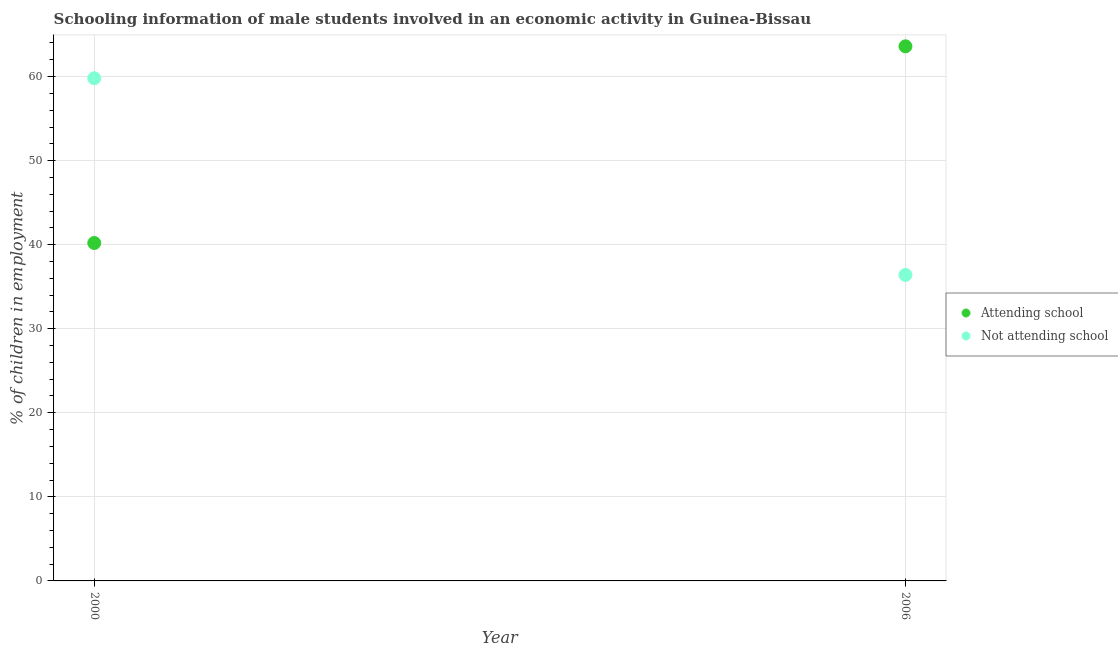How many different coloured dotlines are there?
Your response must be concise. 2. Is the number of dotlines equal to the number of legend labels?
Provide a succinct answer. Yes. What is the percentage of employed males who are attending school in 2000?
Keep it short and to the point. 40.2. Across all years, what is the maximum percentage of employed males who are not attending school?
Ensure brevity in your answer.  59.8. Across all years, what is the minimum percentage of employed males who are attending school?
Provide a succinct answer. 40.2. In which year was the percentage of employed males who are not attending school minimum?
Keep it short and to the point. 2006. What is the total percentage of employed males who are attending school in the graph?
Provide a short and direct response. 103.8. What is the difference between the percentage of employed males who are attending school in 2000 and that in 2006?
Offer a very short reply. -23.4. What is the difference between the percentage of employed males who are attending school in 2006 and the percentage of employed males who are not attending school in 2000?
Offer a terse response. 3.8. What is the average percentage of employed males who are attending school per year?
Provide a succinct answer. 51.9. In the year 2000, what is the difference between the percentage of employed males who are not attending school and percentage of employed males who are attending school?
Keep it short and to the point. 19.6. In how many years, is the percentage of employed males who are not attending school greater than 18 %?
Ensure brevity in your answer.  2. What is the ratio of the percentage of employed males who are attending school in 2000 to that in 2006?
Your response must be concise. 0.63. Is the percentage of employed males who are attending school in 2000 less than that in 2006?
Your answer should be compact. Yes. Is the percentage of employed males who are attending school strictly greater than the percentage of employed males who are not attending school over the years?
Keep it short and to the point. No. Is the percentage of employed males who are not attending school strictly less than the percentage of employed males who are attending school over the years?
Give a very brief answer. No. Are the values on the major ticks of Y-axis written in scientific E-notation?
Offer a very short reply. No. Does the graph contain grids?
Provide a short and direct response. Yes. Where does the legend appear in the graph?
Your answer should be compact. Center right. What is the title of the graph?
Ensure brevity in your answer.  Schooling information of male students involved in an economic activity in Guinea-Bissau. What is the label or title of the Y-axis?
Keep it short and to the point. % of children in employment. What is the % of children in employment in Attending school in 2000?
Offer a very short reply. 40.2. What is the % of children in employment of Not attending school in 2000?
Ensure brevity in your answer.  59.8. What is the % of children in employment in Attending school in 2006?
Provide a short and direct response. 63.6. What is the % of children in employment in Not attending school in 2006?
Offer a terse response. 36.4. Across all years, what is the maximum % of children in employment of Attending school?
Offer a terse response. 63.6. Across all years, what is the maximum % of children in employment in Not attending school?
Ensure brevity in your answer.  59.8. Across all years, what is the minimum % of children in employment in Attending school?
Provide a succinct answer. 40.2. Across all years, what is the minimum % of children in employment of Not attending school?
Make the answer very short. 36.4. What is the total % of children in employment of Attending school in the graph?
Offer a very short reply. 103.8. What is the total % of children in employment of Not attending school in the graph?
Provide a succinct answer. 96.2. What is the difference between the % of children in employment in Attending school in 2000 and that in 2006?
Provide a short and direct response. -23.4. What is the difference between the % of children in employment in Not attending school in 2000 and that in 2006?
Your answer should be very brief. 23.4. What is the difference between the % of children in employment of Attending school in 2000 and the % of children in employment of Not attending school in 2006?
Ensure brevity in your answer.  3.8. What is the average % of children in employment of Attending school per year?
Keep it short and to the point. 51.9. What is the average % of children in employment in Not attending school per year?
Provide a succinct answer. 48.1. In the year 2000, what is the difference between the % of children in employment in Attending school and % of children in employment in Not attending school?
Provide a succinct answer. -19.6. In the year 2006, what is the difference between the % of children in employment of Attending school and % of children in employment of Not attending school?
Ensure brevity in your answer.  27.2. What is the ratio of the % of children in employment of Attending school in 2000 to that in 2006?
Offer a terse response. 0.63. What is the ratio of the % of children in employment of Not attending school in 2000 to that in 2006?
Provide a succinct answer. 1.64. What is the difference between the highest and the second highest % of children in employment of Attending school?
Offer a very short reply. 23.4. What is the difference between the highest and the second highest % of children in employment in Not attending school?
Give a very brief answer. 23.4. What is the difference between the highest and the lowest % of children in employment in Attending school?
Your answer should be very brief. 23.4. What is the difference between the highest and the lowest % of children in employment in Not attending school?
Provide a short and direct response. 23.4. 